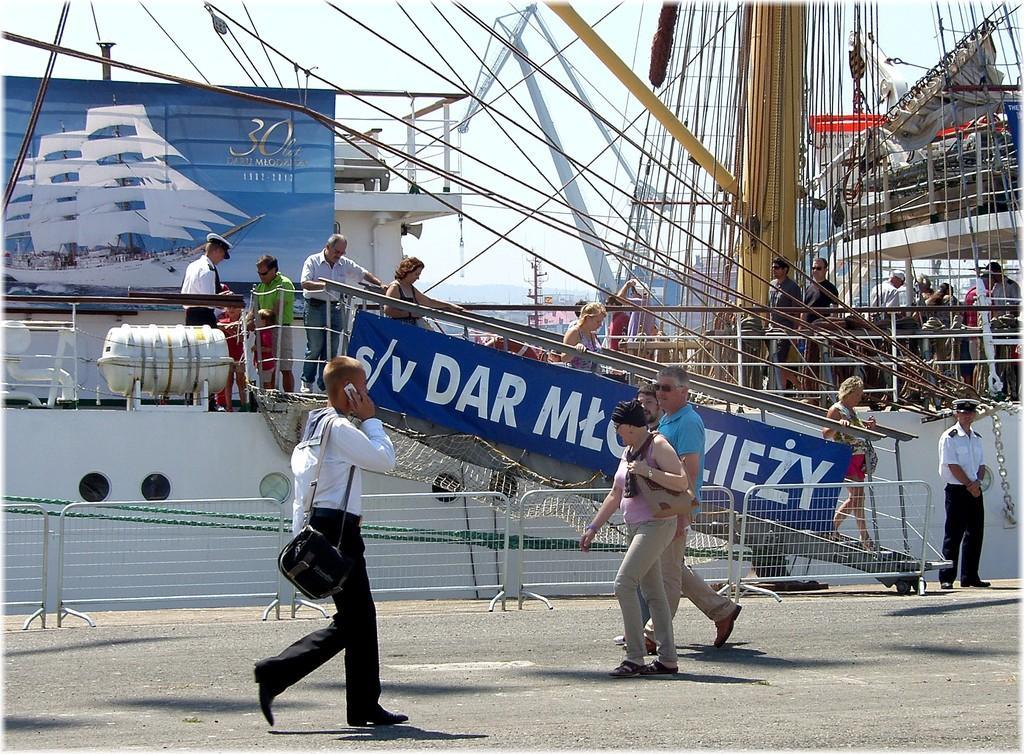Could you give a brief overview of what you see in this image? In front of the picture, we see people walking on the road. Beside them, we see people walking down the stairs. Behind them, we see people are standing. On the right side, we see people are standing. Behind him, we see many rupees. On the left side, we see a board in blue color. In the background, we see buildings and poles. At the top, we see the sky. 